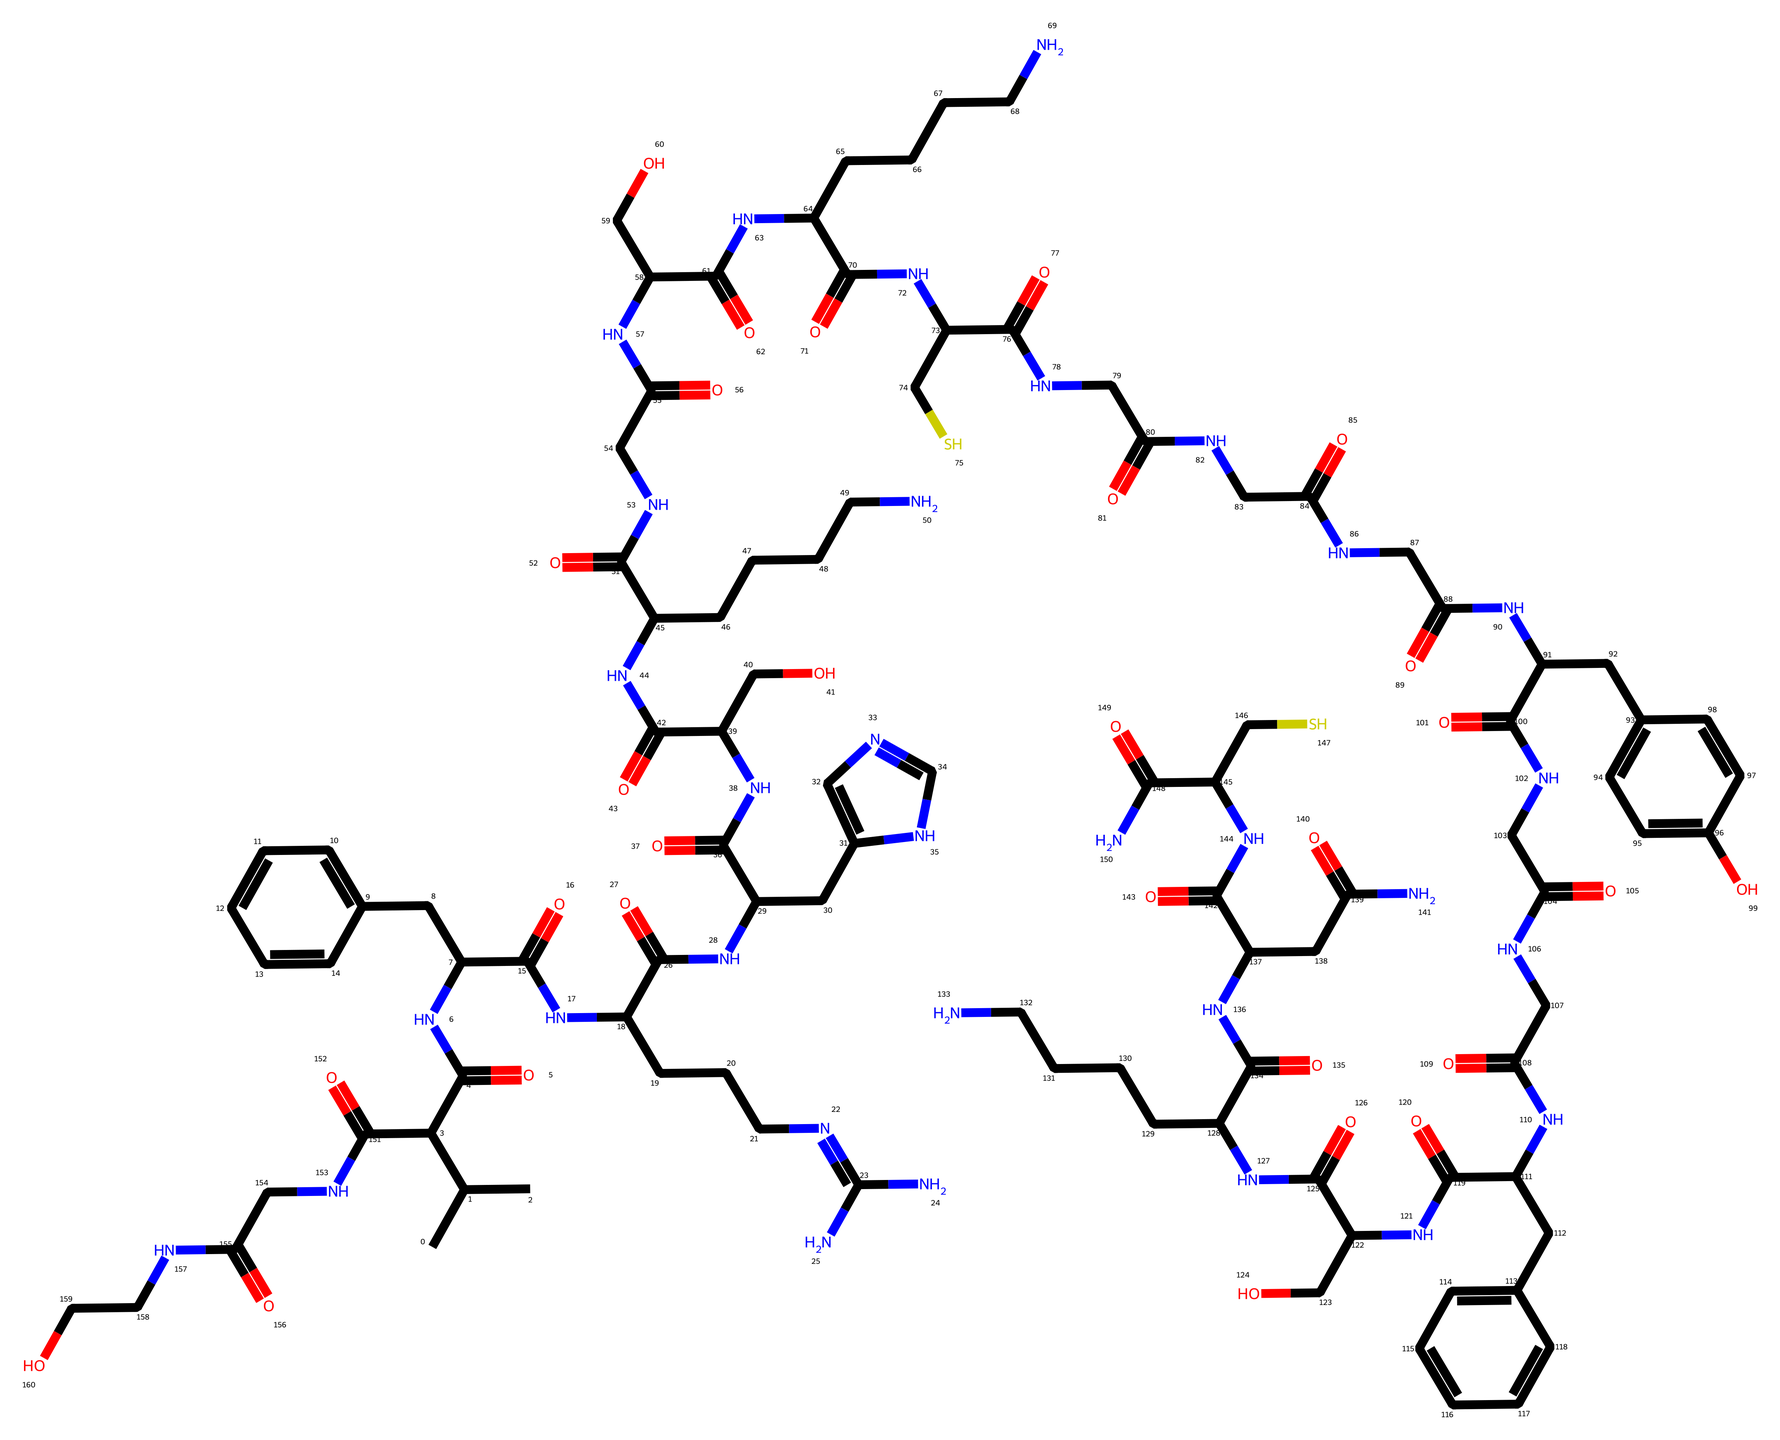What is the total number of nitrogen atoms in this chemical? By analyzing the SMILES representation, we can count the nitrogen atoms present. The segments containing "N" represent nitrogen atoms. In this case, there are 9 nitrogen atoms identified throughout the structure.
Answer: 9 What functional groups can be identified in this chemical? Functional groups can be recognized by inspecting the structural features in the SMILES. The presence of "C(=O)" indicates carbonyl groups (ketones and amides), while "NC" segments represent amines. This chemical features multiple amides and hydroxyl groups due to the "CO" segments.
Answer: amides and hydroxyls How many carbon atoms are present in this compound? The total number of carbon atoms can be calculated by counting all the carbon symbols "C" in the provided SMILES string. After thorough examination, there are 23 carbon atoms in the structure.
Answer: 23 What type of chemical is this classified as? This chemical contains both peptide bonds and multiple nitrogen groups, suggesting it is a peptide. Additionally, its purpose relates to antimicrobial applications, indicating it is a type of antimicrobial peptide drug.
Answer: antimicrobial peptide Are there any aromatic rings in the structure? Aromatic rings can be identified by patterns of alternating double bonds and specific cyclic structures in the SMILES. In this case, there are two aromatic rings represented by the "CC1=CC=CC=C1" and "CC4=CC=CC=C4" segments.
Answer: yes Which atom is likely responsible for the antimicrobial activity? Antimicrobial activity often involves the presence of functional groups that can interact with bacterial membranes. In this case, the presence of positively charged nitrogen-containing segments and hydrophobic carbon structures suggests these regions may contribute significantly to the activity of the antimicrobial peptide.
Answer: nitrogen atoms 